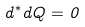Convert formula to latex. <formula><loc_0><loc_0><loc_500><loc_500>d ^ { * } d Q = 0</formula> 